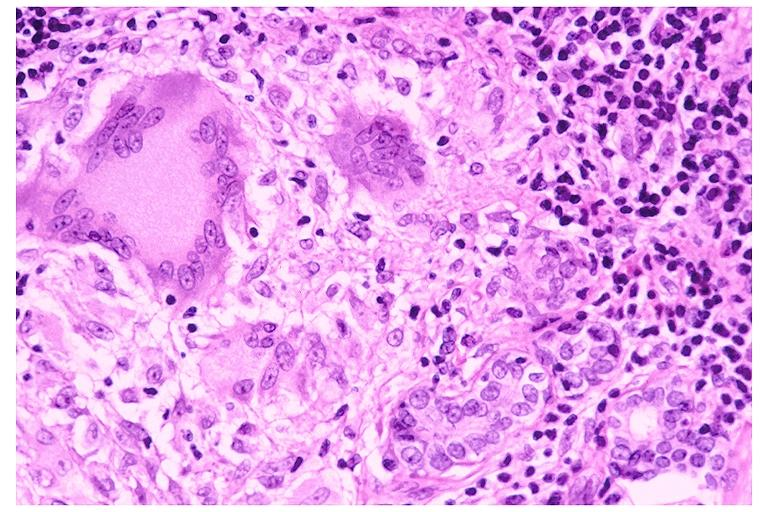does this image show sarcoidosis?
Answer the question using a single word or phrase. Yes 